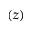<formula> <loc_0><loc_0><loc_500><loc_500>( z )</formula> 